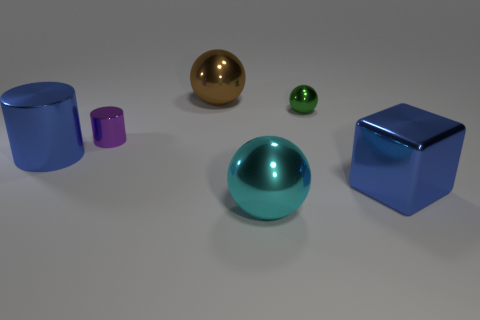There is a large thing behind the small metal sphere; is its shape the same as the small thing on the right side of the brown thing?
Your response must be concise. Yes. How big is the object that is to the right of the cyan sphere and in front of the tiny green metallic thing?
Give a very brief answer. Large. How many other objects are the same color as the tiny cylinder?
Provide a succinct answer. 0. Does the large sphere that is behind the tiny green ball have the same material as the blue cube?
Your response must be concise. Yes. Is there anything else that has the same size as the metallic cube?
Your answer should be compact. Yes. Is the number of large blue objects right of the brown shiny sphere less than the number of metal cubes that are behind the purple cylinder?
Offer a very short reply. No. Is there any other thing that has the same shape as the brown shiny object?
Offer a very short reply. Yes. What material is the big thing that is the same color as the big shiny cylinder?
Your answer should be compact. Metal. What number of brown metallic objects are to the left of the big blue metallic object right of the big ball that is in front of the large cylinder?
Make the answer very short. 1. There is a large brown sphere; what number of tiny things are on the left side of it?
Provide a short and direct response. 1. 